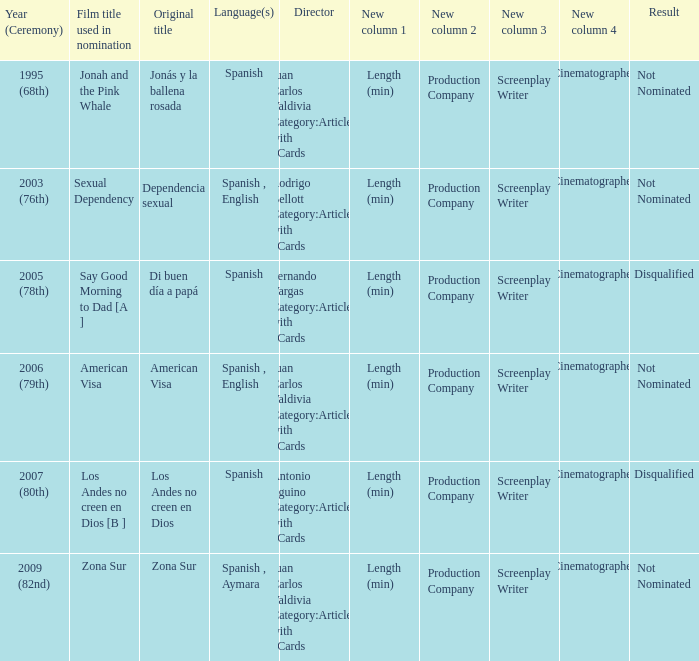What is the film title of dependencia sexual that was utilized for its nomination? Sexual Dependency. 